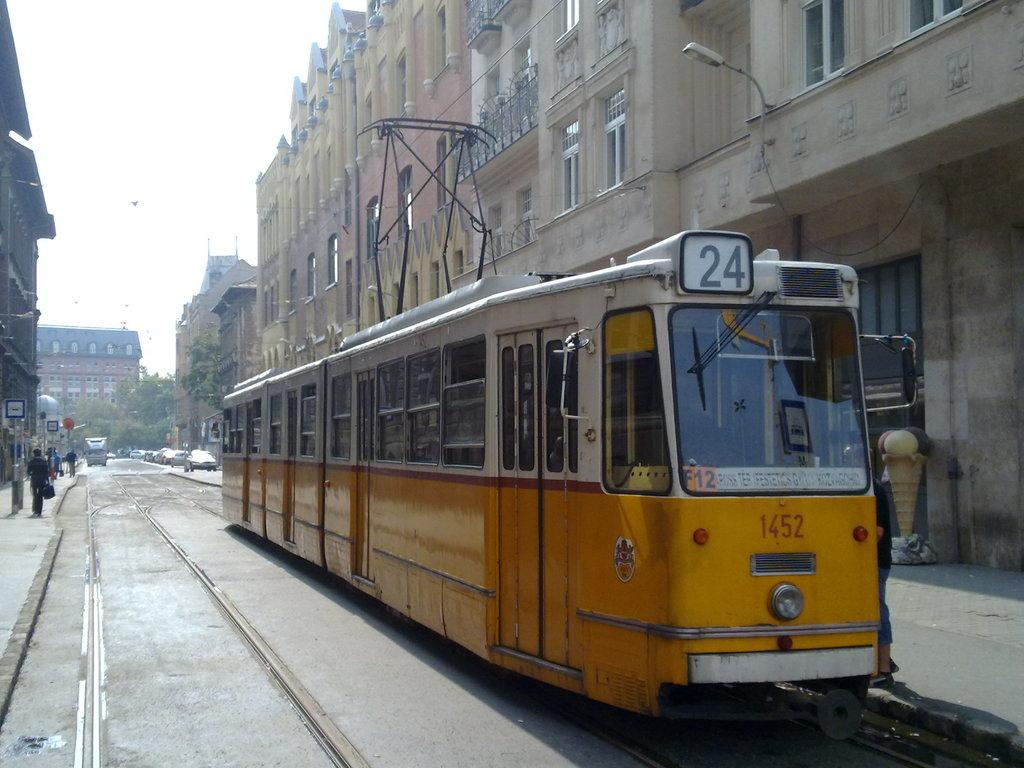<image>
Write a terse but informative summary of the picture. A yellow train that says 1452 on the front is going down an outdoor railway. 